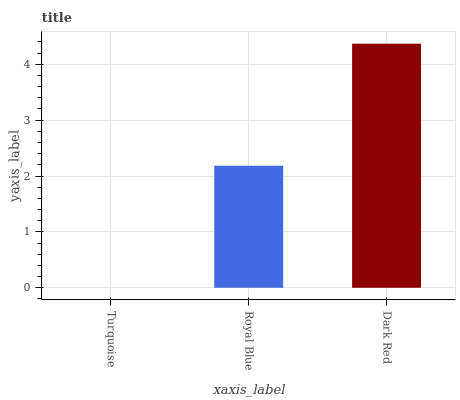Is Turquoise the minimum?
Answer yes or no. Yes. Is Dark Red the maximum?
Answer yes or no. Yes. Is Royal Blue the minimum?
Answer yes or no. No. Is Royal Blue the maximum?
Answer yes or no. No. Is Royal Blue greater than Turquoise?
Answer yes or no. Yes. Is Turquoise less than Royal Blue?
Answer yes or no. Yes. Is Turquoise greater than Royal Blue?
Answer yes or no. No. Is Royal Blue less than Turquoise?
Answer yes or no. No. Is Royal Blue the high median?
Answer yes or no. Yes. Is Royal Blue the low median?
Answer yes or no. Yes. Is Turquoise the high median?
Answer yes or no. No. Is Dark Red the low median?
Answer yes or no. No. 